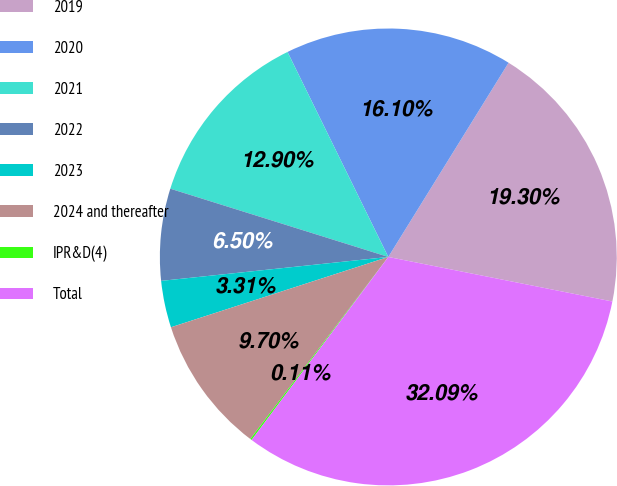Convert chart to OTSL. <chart><loc_0><loc_0><loc_500><loc_500><pie_chart><fcel>2019<fcel>2020<fcel>2021<fcel>2022<fcel>2023<fcel>2024 and thereafter<fcel>IPR&D(4)<fcel>Total<nl><fcel>19.3%<fcel>16.1%<fcel>12.9%<fcel>6.5%<fcel>3.31%<fcel>9.7%<fcel>0.11%<fcel>32.09%<nl></chart> 